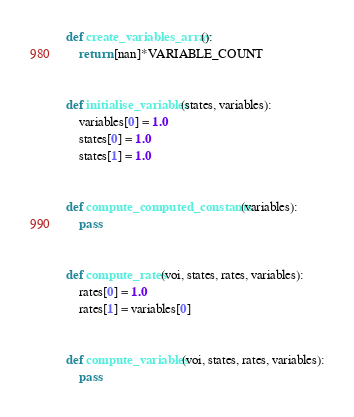<code> <loc_0><loc_0><loc_500><loc_500><_Python_>
def create_variables_array():
    return [nan]*VARIABLE_COUNT


def initialise_variables(states, variables):
    variables[0] = 1.0
    states[0] = 1.0
    states[1] = 1.0


def compute_computed_constants(variables):
    pass


def compute_rates(voi, states, rates, variables):
    rates[0] = 1.0
    rates[1] = variables[0]


def compute_variables(voi, states, rates, variables):
    pass
</code> 